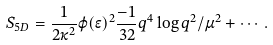<formula> <loc_0><loc_0><loc_500><loc_500>S _ { 5 D } = \frac { 1 } { 2 \kappa ^ { 2 } } \varphi ( \epsilon ) ^ { 2 } \frac { - 1 } { 3 2 } q ^ { 4 } \log q ^ { 2 } / \mu ^ { 2 } + \cdots .</formula> 